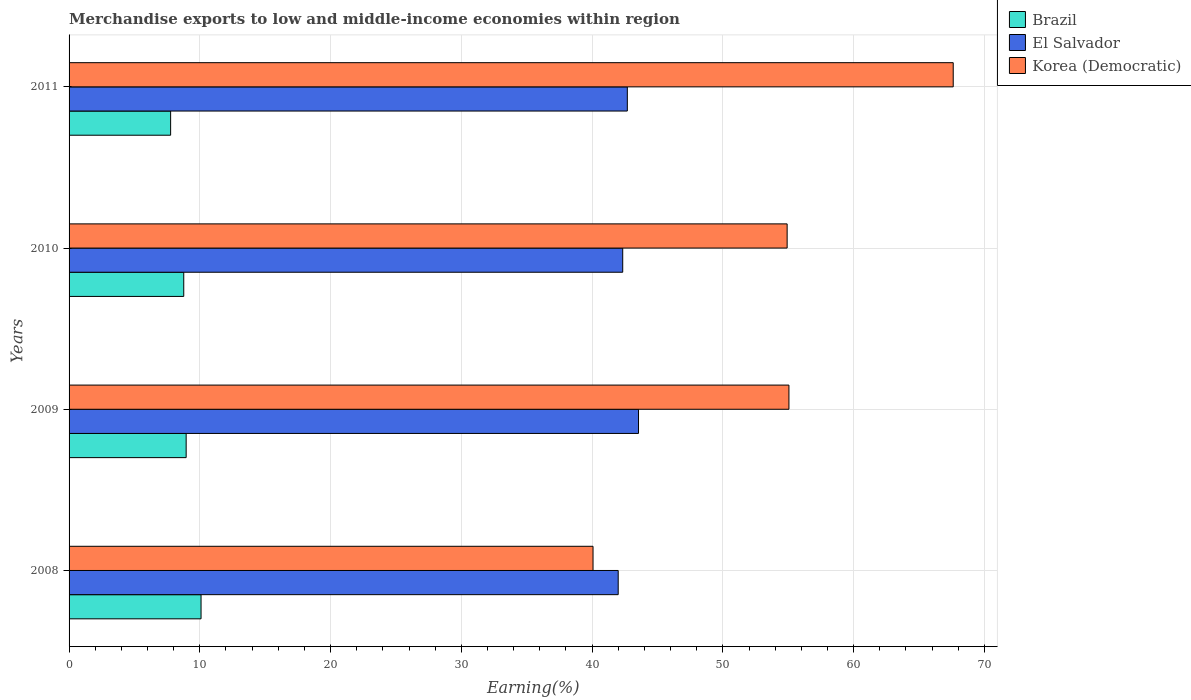How many different coloured bars are there?
Provide a short and direct response. 3. How many groups of bars are there?
Your response must be concise. 4. How many bars are there on the 1st tick from the bottom?
Keep it short and to the point. 3. What is the percentage of amount earned from merchandise exports in El Salvador in 2011?
Ensure brevity in your answer.  42.69. Across all years, what is the maximum percentage of amount earned from merchandise exports in Korea (Democratic)?
Provide a short and direct response. 67.61. Across all years, what is the minimum percentage of amount earned from merchandise exports in Brazil?
Your response must be concise. 7.77. In which year was the percentage of amount earned from merchandise exports in Brazil maximum?
Offer a very short reply. 2008. In which year was the percentage of amount earned from merchandise exports in Korea (Democratic) minimum?
Ensure brevity in your answer.  2008. What is the total percentage of amount earned from merchandise exports in Korea (Democratic) in the graph?
Provide a short and direct response. 217.64. What is the difference between the percentage of amount earned from merchandise exports in El Salvador in 2008 and that in 2009?
Provide a short and direct response. -1.55. What is the difference between the percentage of amount earned from merchandise exports in El Salvador in 2009 and the percentage of amount earned from merchandise exports in Brazil in 2011?
Your answer should be compact. 35.78. What is the average percentage of amount earned from merchandise exports in Korea (Democratic) per year?
Provide a short and direct response. 54.41. In the year 2008, what is the difference between the percentage of amount earned from merchandise exports in Korea (Democratic) and percentage of amount earned from merchandise exports in Brazil?
Offer a very short reply. 29.98. In how many years, is the percentage of amount earned from merchandise exports in Korea (Democratic) greater than 48 %?
Provide a short and direct response. 3. What is the ratio of the percentage of amount earned from merchandise exports in El Salvador in 2009 to that in 2010?
Your response must be concise. 1.03. Is the percentage of amount earned from merchandise exports in Brazil in 2009 less than that in 2010?
Your answer should be compact. No. Is the difference between the percentage of amount earned from merchandise exports in Korea (Democratic) in 2010 and 2011 greater than the difference between the percentage of amount earned from merchandise exports in Brazil in 2010 and 2011?
Offer a very short reply. No. What is the difference between the highest and the second highest percentage of amount earned from merchandise exports in Korea (Democratic)?
Make the answer very short. 12.56. What is the difference between the highest and the lowest percentage of amount earned from merchandise exports in Korea (Democratic)?
Give a very brief answer. 27.54. What does the 1st bar from the top in 2009 represents?
Ensure brevity in your answer.  Korea (Democratic). How many bars are there?
Your answer should be very brief. 12. Are all the bars in the graph horizontal?
Provide a succinct answer. Yes. Are the values on the major ticks of X-axis written in scientific E-notation?
Your response must be concise. No. Where does the legend appear in the graph?
Offer a terse response. Top right. What is the title of the graph?
Your response must be concise. Merchandise exports to low and middle-income economies within region. Does "Philippines" appear as one of the legend labels in the graph?
Keep it short and to the point. No. What is the label or title of the X-axis?
Keep it short and to the point. Earning(%). What is the Earning(%) of Brazil in 2008?
Provide a short and direct response. 10.09. What is the Earning(%) in El Salvador in 2008?
Offer a very short reply. 41.99. What is the Earning(%) in Korea (Democratic) in 2008?
Your answer should be very brief. 40.07. What is the Earning(%) of Brazil in 2009?
Your answer should be very brief. 8.95. What is the Earning(%) of El Salvador in 2009?
Offer a very short reply. 43.55. What is the Earning(%) of Korea (Democratic) in 2009?
Offer a very short reply. 55.05. What is the Earning(%) of Brazil in 2010?
Provide a succinct answer. 8.77. What is the Earning(%) of El Salvador in 2010?
Provide a succinct answer. 42.34. What is the Earning(%) in Korea (Democratic) in 2010?
Ensure brevity in your answer.  54.91. What is the Earning(%) in Brazil in 2011?
Make the answer very short. 7.77. What is the Earning(%) in El Salvador in 2011?
Your answer should be compact. 42.69. What is the Earning(%) of Korea (Democratic) in 2011?
Provide a succinct answer. 67.61. Across all years, what is the maximum Earning(%) in Brazil?
Provide a short and direct response. 10.09. Across all years, what is the maximum Earning(%) of El Salvador?
Your response must be concise. 43.55. Across all years, what is the maximum Earning(%) in Korea (Democratic)?
Keep it short and to the point. 67.61. Across all years, what is the minimum Earning(%) of Brazil?
Offer a terse response. 7.77. Across all years, what is the minimum Earning(%) in El Salvador?
Your answer should be very brief. 41.99. Across all years, what is the minimum Earning(%) in Korea (Democratic)?
Offer a terse response. 40.07. What is the total Earning(%) in Brazil in the graph?
Your response must be concise. 35.58. What is the total Earning(%) of El Salvador in the graph?
Offer a very short reply. 170.57. What is the total Earning(%) in Korea (Democratic) in the graph?
Give a very brief answer. 217.64. What is the difference between the Earning(%) of Brazil in 2008 and that in 2009?
Ensure brevity in your answer.  1.14. What is the difference between the Earning(%) of El Salvador in 2008 and that in 2009?
Your answer should be compact. -1.55. What is the difference between the Earning(%) in Korea (Democratic) in 2008 and that in 2009?
Keep it short and to the point. -14.98. What is the difference between the Earning(%) in Brazil in 2008 and that in 2010?
Provide a succinct answer. 1.32. What is the difference between the Earning(%) in El Salvador in 2008 and that in 2010?
Offer a terse response. -0.35. What is the difference between the Earning(%) in Korea (Democratic) in 2008 and that in 2010?
Offer a very short reply. -14.84. What is the difference between the Earning(%) of Brazil in 2008 and that in 2011?
Provide a succinct answer. 2.33. What is the difference between the Earning(%) in El Salvador in 2008 and that in 2011?
Provide a short and direct response. -0.7. What is the difference between the Earning(%) in Korea (Democratic) in 2008 and that in 2011?
Keep it short and to the point. -27.54. What is the difference between the Earning(%) of Brazil in 2009 and that in 2010?
Keep it short and to the point. 0.18. What is the difference between the Earning(%) of El Salvador in 2009 and that in 2010?
Provide a short and direct response. 1.21. What is the difference between the Earning(%) of Korea (Democratic) in 2009 and that in 2010?
Keep it short and to the point. 0.14. What is the difference between the Earning(%) in Brazil in 2009 and that in 2011?
Offer a very short reply. 1.19. What is the difference between the Earning(%) in El Salvador in 2009 and that in 2011?
Your response must be concise. 0.85. What is the difference between the Earning(%) of Korea (Democratic) in 2009 and that in 2011?
Ensure brevity in your answer.  -12.56. What is the difference between the Earning(%) of El Salvador in 2010 and that in 2011?
Provide a short and direct response. -0.35. What is the difference between the Earning(%) in Korea (Democratic) in 2010 and that in 2011?
Ensure brevity in your answer.  -12.7. What is the difference between the Earning(%) of Brazil in 2008 and the Earning(%) of El Salvador in 2009?
Your answer should be compact. -33.45. What is the difference between the Earning(%) of Brazil in 2008 and the Earning(%) of Korea (Democratic) in 2009?
Keep it short and to the point. -44.96. What is the difference between the Earning(%) in El Salvador in 2008 and the Earning(%) in Korea (Democratic) in 2009?
Offer a very short reply. -13.06. What is the difference between the Earning(%) in Brazil in 2008 and the Earning(%) in El Salvador in 2010?
Your answer should be compact. -32.25. What is the difference between the Earning(%) in Brazil in 2008 and the Earning(%) in Korea (Democratic) in 2010?
Provide a short and direct response. -44.82. What is the difference between the Earning(%) in El Salvador in 2008 and the Earning(%) in Korea (Democratic) in 2010?
Ensure brevity in your answer.  -12.92. What is the difference between the Earning(%) of Brazil in 2008 and the Earning(%) of El Salvador in 2011?
Your response must be concise. -32.6. What is the difference between the Earning(%) in Brazil in 2008 and the Earning(%) in Korea (Democratic) in 2011?
Provide a succinct answer. -57.52. What is the difference between the Earning(%) of El Salvador in 2008 and the Earning(%) of Korea (Democratic) in 2011?
Provide a succinct answer. -25.62. What is the difference between the Earning(%) of Brazil in 2009 and the Earning(%) of El Salvador in 2010?
Offer a terse response. -33.39. What is the difference between the Earning(%) of Brazil in 2009 and the Earning(%) of Korea (Democratic) in 2010?
Provide a succinct answer. -45.96. What is the difference between the Earning(%) in El Salvador in 2009 and the Earning(%) in Korea (Democratic) in 2010?
Provide a succinct answer. -11.37. What is the difference between the Earning(%) in Brazil in 2009 and the Earning(%) in El Salvador in 2011?
Provide a short and direct response. -33.74. What is the difference between the Earning(%) of Brazil in 2009 and the Earning(%) of Korea (Democratic) in 2011?
Provide a succinct answer. -58.66. What is the difference between the Earning(%) of El Salvador in 2009 and the Earning(%) of Korea (Democratic) in 2011?
Provide a short and direct response. -24.07. What is the difference between the Earning(%) in Brazil in 2010 and the Earning(%) in El Salvador in 2011?
Keep it short and to the point. -33.92. What is the difference between the Earning(%) of Brazil in 2010 and the Earning(%) of Korea (Democratic) in 2011?
Offer a very short reply. -58.84. What is the difference between the Earning(%) in El Salvador in 2010 and the Earning(%) in Korea (Democratic) in 2011?
Make the answer very short. -25.27. What is the average Earning(%) in Brazil per year?
Your answer should be compact. 8.9. What is the average Earning(%) in El Salvador per year?
Offer a very short reply. 42.64. What is the average Earning(%) of Korea (Democratic) per year?
Your response must be concise. 54.41. In the year 2008, what is the difference between the Earning(%) in Brazil and Earning(%) in El Salvador?
Provide a short and direct response. -31.9. In the year 2008, what is the difference between the Earning(%) in Brazil and Earning(%) in Korea (Democratic)?
Give a very brief answer. -29.98. In the year 2008, what is the difference between the Earning(%) in El Salvador and Earning(%) in Korea (Democratic)?
Keep it short and to the point. 1.92. In the year 2009, what is the difference between the Earning(%) of Brazil and Earning(%) of El Salvador?
Provide a succinct answer. -34.59. In the year 2009, what is the difference between the Earning(%) of Brazil and Earning(%) of Korea (Democratic)?
Your response must be concise. -46.1. In the year 2009, what is the difference between the Earning(%) of El Salvador and Earning(%) of Korea (Democratic)?
Give a very brief answer. -11.5. In the year 2010, what is the difference between the Earning(%) in Brazil and Earning(%) in El Salvador?
Your answer should be compact. -33.57. In the year 2010, what is the difference between the Earning(%) in Brazil and Earning(%) in Korea (Democratic)?
Keep it short and to the point. -46.14. In the year 2010, what is the difference between the Earning(%) in El Salvador and Earning(%) in Korea (Democratic)?
Your response must be concise. -12.57. In the year 2011, what is the difference between the Earning(%) of Brazil and Earning(%) of El Salvador?
Offer a very short reply. -34.93. In the year 2011, what is the difference between the Earning(%) of Brazil and Earning(%) of Korea (Democratic)?
Make the answer very short. -59.85. In the year 2011, what is the difference between the Earning(%) in El Salvador and Earning(%) in Korea (Democratic)?
Your answer should be compact. -24.92. What is the ratio of the Earning(%) of Brazil in 2008 to that in 2009?
Offer a terse response. 1.13. What is the ratio of the Earning(%) in Korea (Democratic) in 2008 to that in 2009?
Provide a succinct answer. 0.73. What is the ratio of the Earning(%) in Brazil in 2008 to that in 2010?
Your answer should be compact. 1.15. What is the ratio of the Earning(%) of Korea (Democratic) in 2008 to that in 2010?
Provide a succinct answer. 0.73. What is the ratio of the Earning(%) of Brazil in 2008 to that in 2011?
Give a very brief answer. 1.3. What is the ratio of the Earning(%) in El Salvador in 2008 to that in 2011?
Provide a short and direct response. 0.98. What is the ratio of the Earning(%) in Korea (Democratic) in 2008 to that in 2011?
Offer a terse response. 0.59. What is the ratio of the Earning(%) in Brazil in 2009 to that in 2010?
Your response must be concise. 1.02. What is the ratio of the Earning(%) of El Salvador in 2009 to that in 2010?
Offer a very short reply. 1.03. What is the ratio of the Earning(%) in Korea (Democratic) in 2009 to that in 2010?
Your answer should be very brief. 1. What is the ratio of the Earning(%) in Brazil in 2009 to that in 2011?
Provide a succinct answer. 1.15. What is the ratio of the Earning(%) in Korea (Democratic) in 2009 to that in 2011?
Your response must be concise. 0.81. What is the ratio of the Earning(%) of Brazil in 2010 to that in 2011?
Your answer should be very brief. 1.13. What is the ratio of the Earning(%) of El Salvador in 2010 to that in 2011?
Make the answer very short. 0.99. What is the ratio of the Earning(%) of Korea (Democratic) in 2010 to that in 2011?
Make the answer very short. 0.81. What is the difference between the highest and the second highest Earning(%) in Brazil?
Provide a short and direct response. 1.14. What is the difference between the highest and the second highest Earning(%) in El Salvador?
Your response must be concise. 0.85. What is the difference between the highest and the second highest Earning(%) in Korea (Democratic)?
Make the answer very short. 12.56. What is the difference between the highest and the lowest Earning(%) of Brazil?
Keep it short and to the point. 2.33. What is the difference between the highest and the lowest Earning(%) of El Salvador?
Give a very brief answer. 1.55. What is the difference between the highest and the lowest Earning(%) in Korea (Democratic)?
Ensure brevity in your answer.  27.54. 